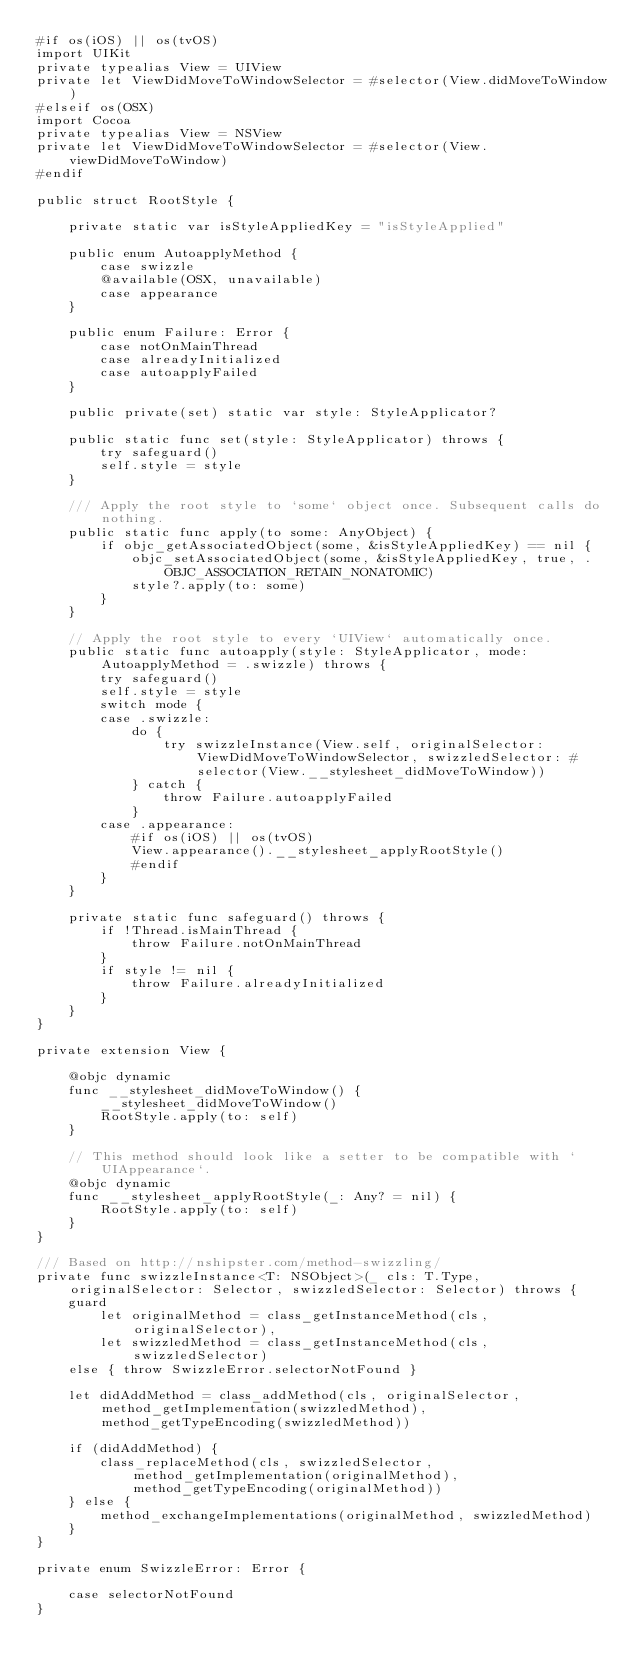Convert code to text. <code><loc_0><loc_0><loc_500><loc_500><_Swift_>#if os(iOS) || os(tvOS)
import UIKit
private typealias View = UIView
private let ViewDidMoveToWindowSelector = #selector(View.didMoveToWindow)
#elseif os(OSX)
import Cocoa
private typealias View = NSView
private let ViewDidMoveToWindowSelector = #selector(View.viewDidMoveToWindow)
#endif

public struct RootStyle {

    private static var isStyleAppliedKey = "isStyleApplied"

    public enum AutoapplyMethod {
        case swizzle
        @available(OSX, unavailable)
        case appearance
    }

    public enum Failure: Error {
        case notOnMainThread
        case alreadyInitialized
        case autoapplyFailed
    }

    public private(set) static var style: StyleApplicator?

    public static func set(style: StyleApplicator) throws {
        try safeguard()
        self.style = style
    }

    /// Apply the root style to `some` object once. Subsequent calls do nothing.
    public static func apply(to some: AnyObject) {
        if objc_getAssociatedObject(some, &isStyleAppliedKey) == nil {
            objc_setAssociatedObject(some, &isStyleAppliedKey, true, .OBJC_ASSOCIATION_RETAIN_NONATOMIC)
            style?.apply(to: some)
        }
    }

    // Apply the root style to every `UIView` automatically once.
    public static func autoapply(style: StyleApplicator, mode: AutoapplyMethod = .swizzle) throws {
        try safeguard()
        self.style = style
        switch mode {
        case .swizzle:
            do {
                try swizzleInstance(View.self, originalSelector: ViewDidMoveToWindowSelector, swizzledSelector: #selector(View.__stylesheet_didMoveToWindow))
            } catch {
                throw Failure.autoapplyFailed
            }
        case .appearance:
            #if os(iOS) || os(tvOS)
            View.appearance().__stylesheet_applyRootStyle()
            #endif
        }
    }

    private static func safeguard() throws {
        if !Thread.isMainThread {
            throw Failure.notOnMainThread
        }
        if style != nil {
            throw Failure.alreadyInitialized
        }
    }
}

private extension View {

    @objc dynamic
    func __stylesheet_didMoveToWindow() {
        __stylesheet_didMoveToWindow()
        RootStyle.apply(to: self)
    }

    // This method should look like a setter to be compatible with `UIAppearance`.
    @objc dynamic
    func __stylesheet_applyRootStyle(_: Any? = nil) {
        RootStyle.apply(to: self)
    }
}

/// Based on http://nshipster.com/method-swizzling/
private func swizzleInstance<T: NSObject>(_ cls: T.Type, originalSelector: Selector, swizzledSelector: Selector) throws {
    guard
        let originalMethod = class_getInstanceMethod(cls, originalSelector),
        let swizzledMethod = class_getInstanceMethod(cls, swizzledSelector)
    else { throw SwizzleError.selectorNotFound }

    let didAddMethod = class_addMethod(cls, originalSelector, method_getImplementation(swizzledMethod), method_getTypeEncoding(swizzledMethod))

    if (didAddMethod) {
        class_replaceMethod(cls, swizzledSelector, method_getImplementation(originalMethod), method_getTypeEncoding(originalMethod))
    } else {
        method_exchangeImplementations(originalMethod, swizzledMethod)
    }
}

private enum SwizzleError: Error {

    case selectorNotFound
}
</code> 